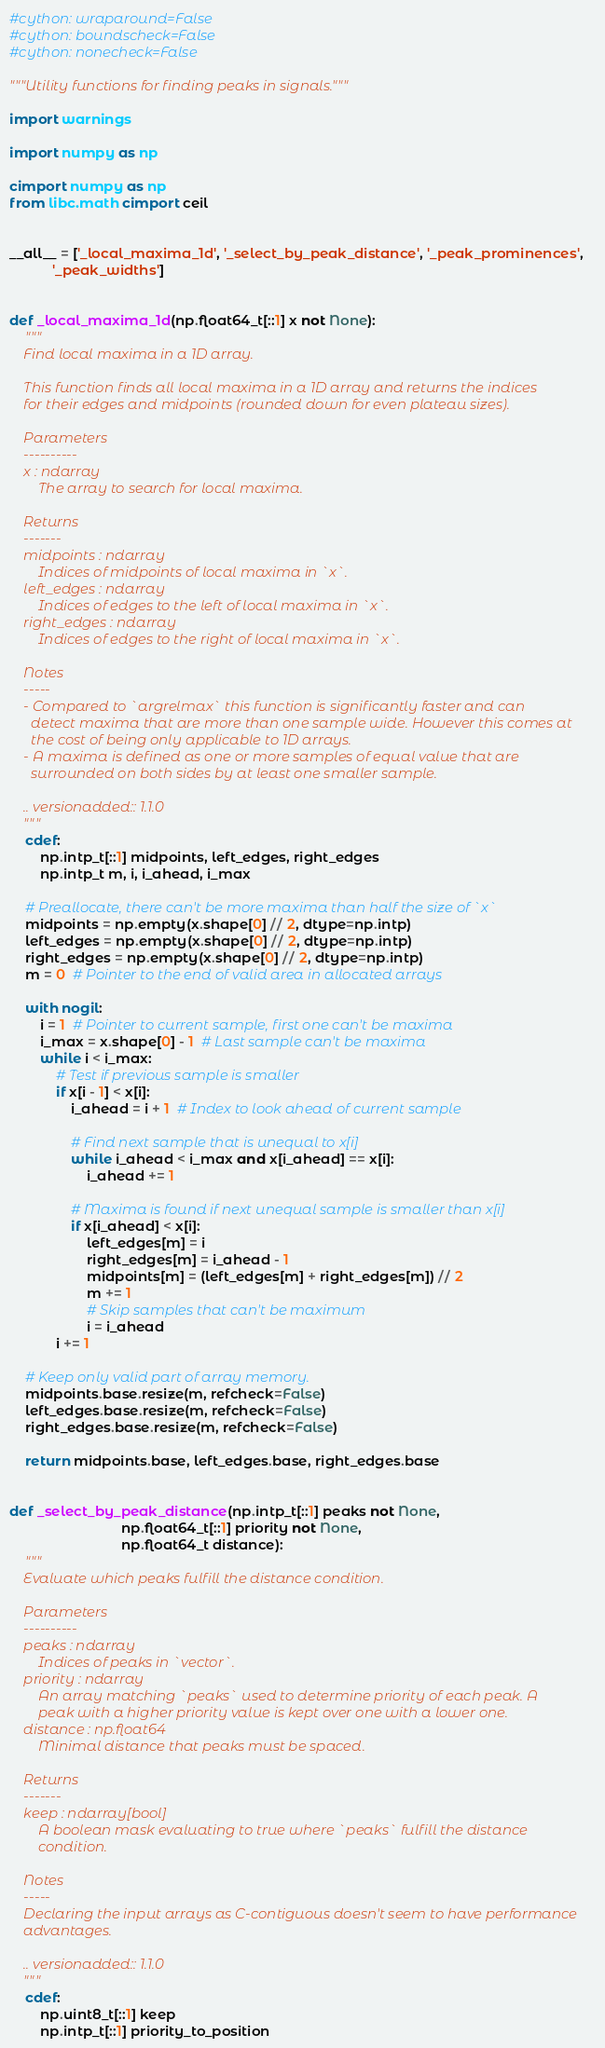Convert code to text. <code><loc_0><loc_0><loc_500><loc_500><_Cython_>#cython: wraparound=False
#cython: boundscheck=False
#cython: nonecheck=False

"""Utility functions for finding peaks in signals."""

import warnings

import numpy as np

cimport numpy as np
from libc.math cimport ceil


__all__ = ['_local_maxima_1d', '_select_by_peak_distance', '_peak_prominences',
           '_peak_widths']


def _local_maxima_1d(np.float64_t[::1] x not None):
    """
    Find local maxima in a 1D array.

    This function finds all local maxima in a 1D array and returns the indices
    for their edges and midpoints (rounded down for even plateau sizes).

    Parameters
    ----------
    x : ndarray
        The array to search for local maxima.

    Returns
    -------
    midpoints : ndarray
        Indices of midpoints of local maxima in `x`.
    left_edges : ndarray
        Indices of edges to the left of local maxima in `x`.
    right_edges : ndarray
        Indices of edges to the right of local maxima in `x`.

    Notes
    -----
    - Compared to `argrelmax` this function is significantly faster and can
      detect maxima that are more than one sample wide. However this comes at
      the cost of being only applicable to 1D arrays.
    - A maxima is defined as one or more samples of equal value that are
      surrounded on both sides by at least one smaller sample.

    .. versionadded:: 1.1.0
    """
    cdef:
        np.intp_t[::1] midpoints, left_edges, right_edges
        np.intp_t m, i, i_ahead, i_max

    # Preallocate, there can't be more maxima than half the size of `x`
    midpoints = np.empty(x.shape[0] // 2, dtype=np.intp)
    left_edges = np.empty(x.shape[0] // 2, dtype=np.intp)
    right_edges = np.empty(x.shape[0] // 2, dtype=np.intp)
    m = 0  # Pointer to the end of valid area in allocated arrays

    with nogil:
        i = 1  # Pointer to current sample, first one can't be maxima
        i_max = x.shape[0] - 1  # Last sample can't be maxima
        while i < i_max:
            # Test if previous sample is smaller
            if x[i - 1] < x[i]:
                i_ahead = i + 1  # Index to look ahead of current sample

                # Find next sample that is unequal to x[i]
                while i_ahead < i_max and x[i_ahead] == x[i]:
                    i_ahead += 1

                # Maxima is found if next unequal sample is smaller than x[i]
                if x[i_ahead] < x[i]:
                    left_edges[m] = i
                    right_edges[m] = i_ahead - 1
                    midpoints[m] = (left_edges[m] + right_edges[m]) // 2
                    m += 1
                    # Skip samples that can't be maximum
                    i = i_ahead
            i += 1

    # Keep only valid part of array memory.
    midpoints.base.resize(m, refcheck=False)
    left_edges.base.resize(m, refcheck=False)
    right_edges.base.resize(m, refcheck=False)

    return midpoints.base, left_edges.base, right_edges.base


def _select_by_peak_distance(np.intp_t[::1] peaks not None,
                             np.float64_t[::1] priority not None,
                             np.float64_t distance):
    """
    Evaluate which peaks fulfill the distance condition.

    Parameters
    ----------
    peaks : ndarray
        Indices of peaks in `vector`.
    priority : ndarray
        An array matching `peaks` used to determine priority of each peak. A
        peak with a higher priority value is kept over one with a lower one.
    distance : np.float64
        Minimal distance that peaks must be spaced.

    Returns
    -------
    keep : ndarray[bool]
        A boolean mask evaluating to true where `peaks` fulfill the distance
        condition.

    Notes
    -----
    Declaring the input arrays as C-contiguous doesn't seem to have performance
    advantages.

    .. versionadded:: 1.1.0
    """
    cdef:
        np.uint8_t[::1] keep
        np.intp_t[::1] priority_to_position</code> 